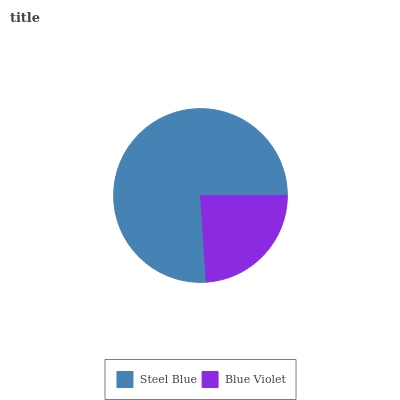Is Blue Violet the minimum?
Answer yes or no. Yes. Is Steel Blue the maximum?
Answer yes or no. Yes. Is Blue Violet the maximum?
Answer yes or no. No. Is Steel Blue greater than Blue Violet?
Answer yes or no. Yes. Is Blue Violet less than Steel Blue?
Answer yes or no. Yes. Is Blue Violet greater than Steel Blue?
Answer yes or no. No. Is Steel Blue less than Blue Violet?
Answer yes or no. No. Is Steel Blue the high median?
Answer yes or no. Yes. Is Blue Violet the low median?
Answer yes or no. Yes. Is Blue Violet the high median?
Answer yes or no. No. Is Steel Blue the low median?
Answer yes or no. No. 